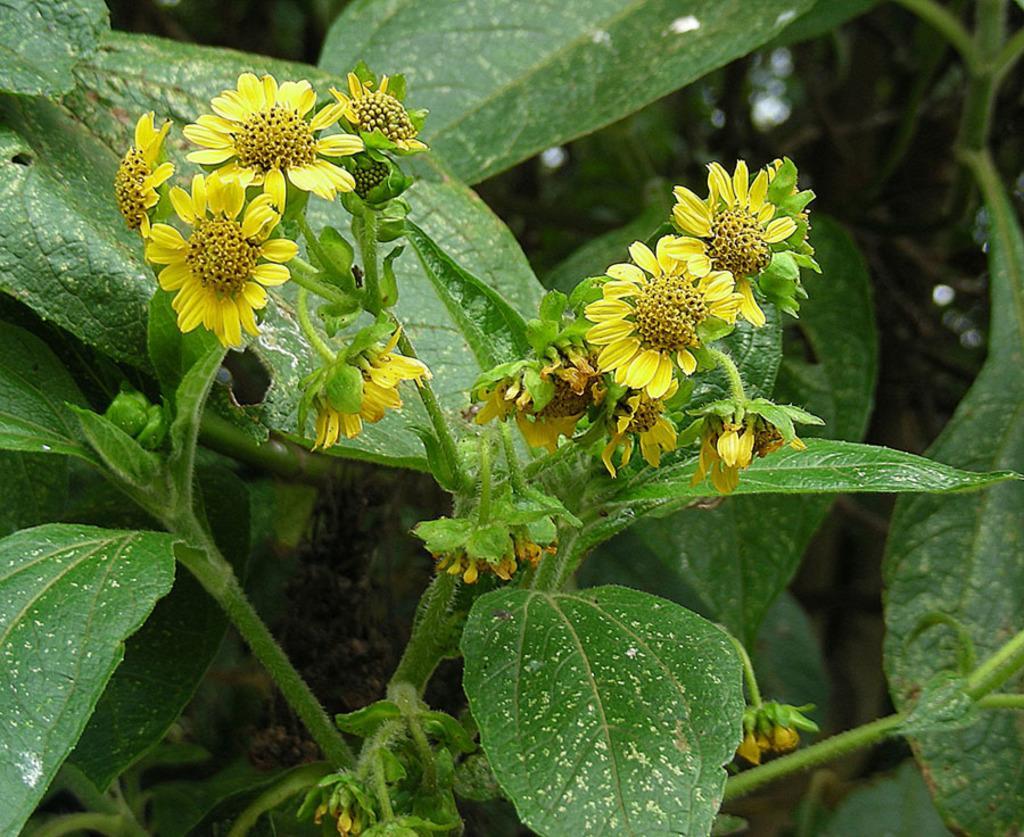Can you describe this image briefly? In this picture I can see a plant with flowers, and there is blur background. 